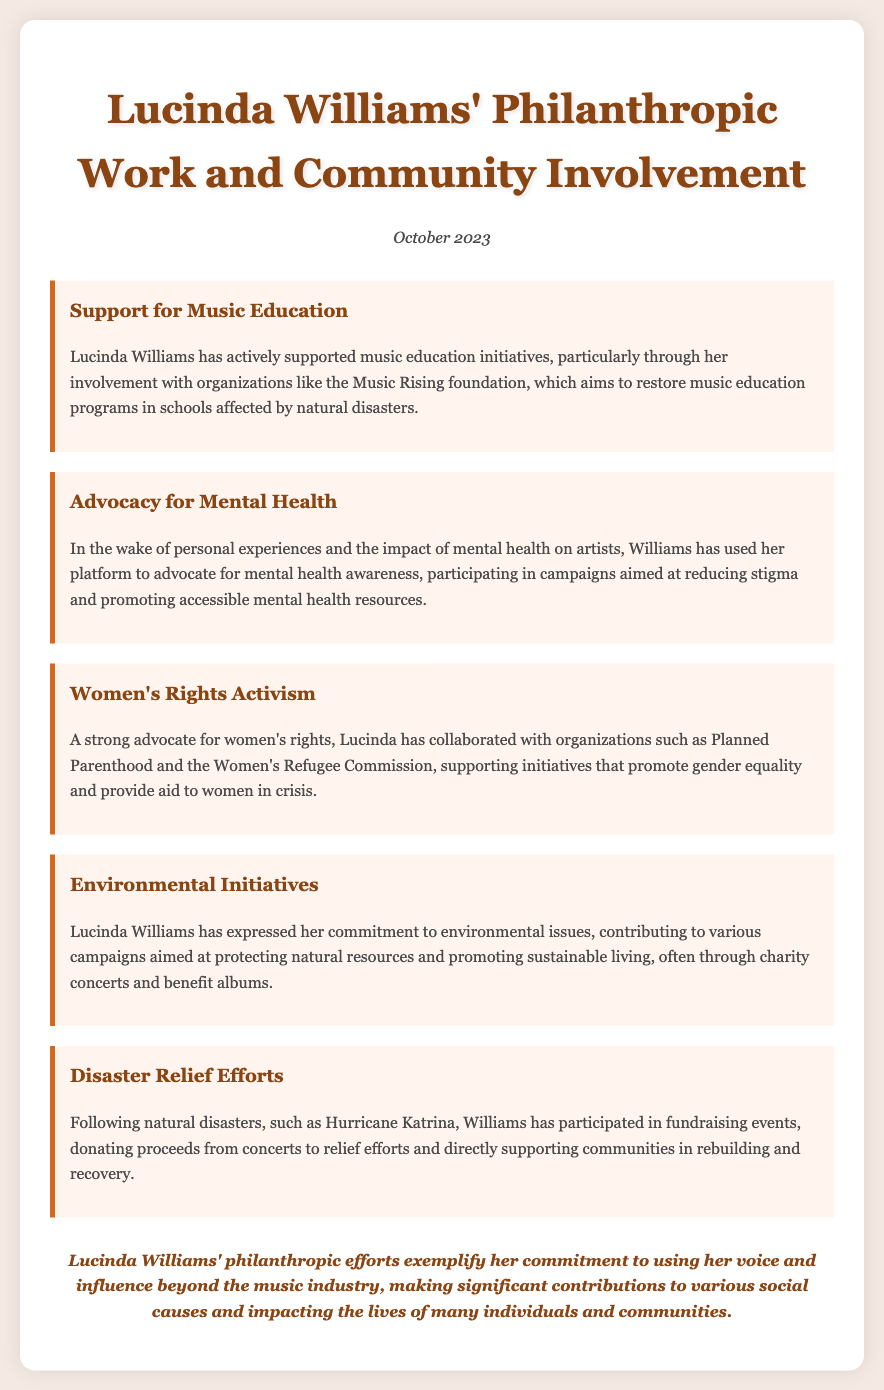What organization supports music education? The document mentions the Music Rising foundation, which aims to restore music education programs.
Answer: Music Rising foundation What cause does Lucinda Williams advocate for regarding artists? Based on her personal experiences, Lucinda advocates for mental health awareness and reducing stigma.
Answer: Mental health Which organization does she collaborate with for women's rights? Lucinda collaborates with Planned Parenthood and the Women's Refugee Commission for women's rights initiatives.
Answer: Planned Parenthood What type of initiatives does Lucinda support for environmental issues? The document states that Lucinda contributes to campaigns aimed at protecting natural resources and promoting sustainable living.
Answer: Environmental initiatives What event prompted Lucinda's participation in fundraising efforts? Lucinda participated in fundraising events following natural disasters, specifically mentioned is Hurricane Katrina.
Answer: Hurricane Katrina Which month and year is the memo dated? The memo is dated October 2023, indicating when the summary was compiled.
Answer: October 2023 What is the overall impact of Lucinda Williams' philanthropic efforts? The document highlights her commitment to social causes and making significant contributions to various communities.
Answer: Significant contributions How does Lucinda raise funds for disaster relief? Proceeds from concerts are donated to relief efforts for communities affected by disasters.
Answer: Concert proceeds 